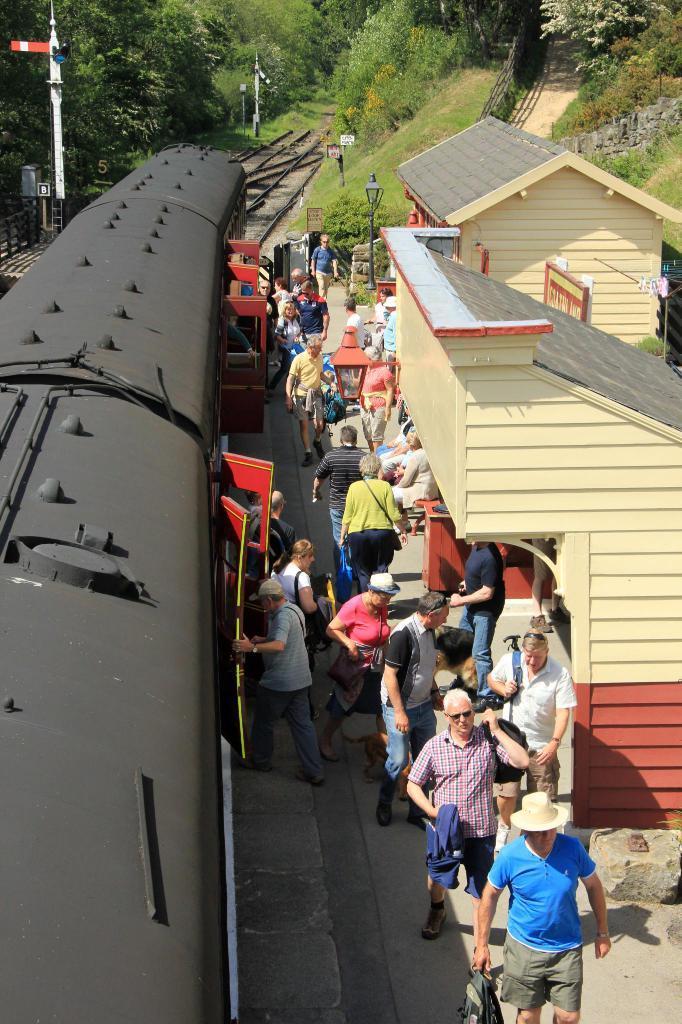Can you describe this image briefly? This picture is taken inside the railway station and it is sunny. In this image, on the right side, we can see a building and group of people walking. On the left side, we can see a train. In the background, we can see electric pole, electrical box, hoardings. At the bottom, we can see the stones in the railway track. 